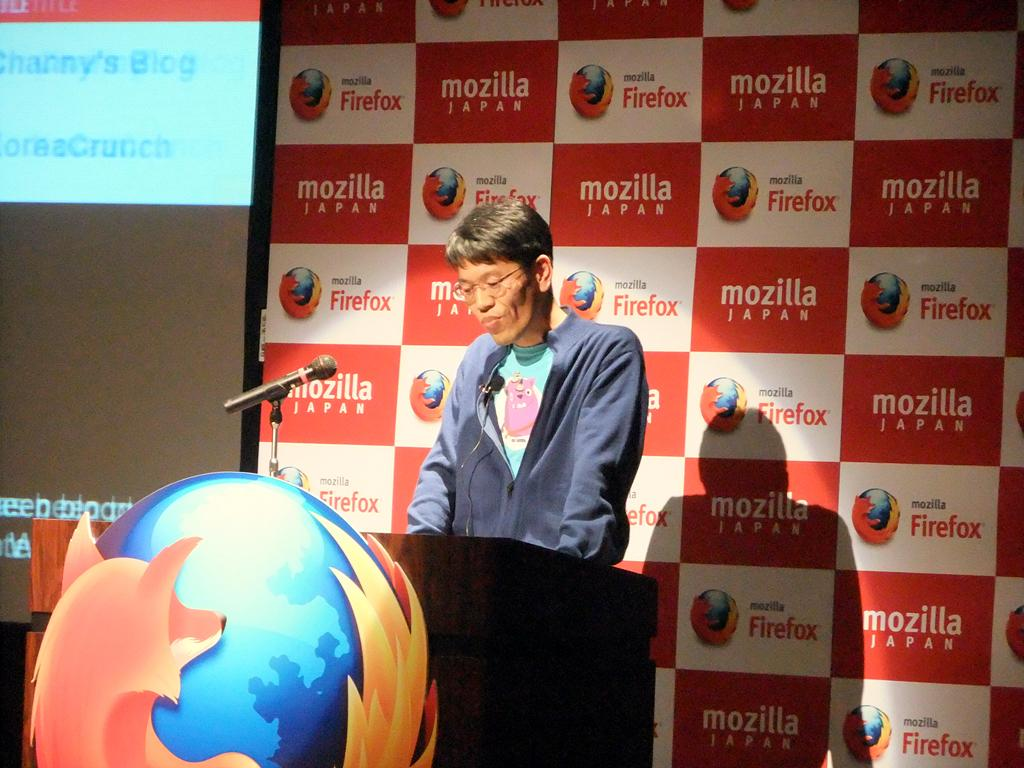What is the main subject of the image? There is a person standing in the image. What is in front of the person? There is a logo and a microphone on a podium in front of the person. What can be seen in the background of the image? There is a screen and a board with words and logos in the background of the image. What type of health advice is the person giving in the image? The image does not provide any information about health advice or the person's role, so it cannot be determined from the image. Can you see a frog on the board in the background of the image? There is no frog present in the image; the board contains words and logos. 